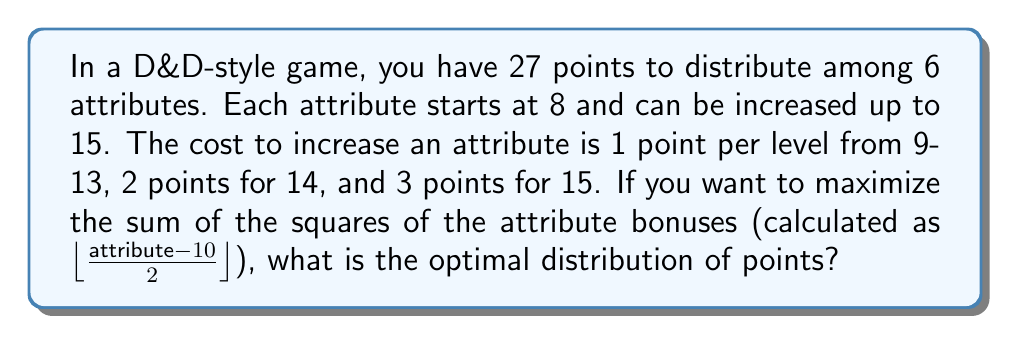What is the answer to this math problem? Let's approach this step-by-step:

1) First, we need to understand the relationship between attribute scores and bonuses:
   8-9: -1 bonus
   10-11: 0 bonus
   12-13: +1 bonus
   14-15: +2 bonus

2) The goal is to maximize $\sum (\text{bonus})^2$

3) Observe that increasing an attribute from 13 to 14 costs 2 points but increases the bonus by 1, while increasing from 14 to 15 costs 3 points for no increase in bonus.

4) Therefore, the optimal strategy will never involve raising an attribute to 15.

5) The most efficient way to spend points is to raise attributes to 14, as this gives the highest bonus (+2) for the points spent.

6) We can raise 3 attributes to 14 with 24 points:
   (14-8) * 1 + 2 = 8 points per attribute
   8 * 3 = 24 points

7) We have 3 points left. The most efficient use is to raise one more attribute to 13:
   (13-8) * 1 = 5 points

8) This leaves us with:
   3 attributes at 14 (+2 bonus each)
   1 attribute at 13 (+1 bonus)
   2 attributes at 8 (-1 bonus each)

9) The sum of the squares of the bonuses is:
   $3(2^2) + 1(1^2) + 2((-1)^2) = 12 + 1 + 2 = 15$

This is the maximum achievable value.
Answer: 14, 14, 14, 13, 8, 8 